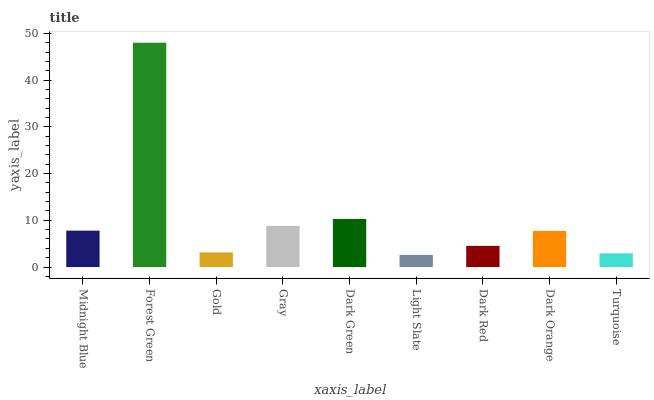Is Light Slate the minimum?
Answer yes or no. Yes. Is Forest Green the maximum?
Answer yes or no. Yes. Is Gold the minimum?
Answer yes or no. No. Is Gold the maximum?
Answer yes or no. No. Is Forest Green greater than Gold?
Answer yes or no. Yes. Is Gold less than Forest Green?
Answer yes or no. Yes. Is Gold greater than Forest Green?
Answer yes or no. No. Is Forest Green less than Gold?
Answer yes or no. No. Is Dark Orange the high median?
Answer yes or no. Yes. Is Dark Orange the low median?
Answer yes or no. Yes. Is Gold the high median?
Answer yes or no. No. Is Midnight Blue the low median?
Answer yes or no. No. 